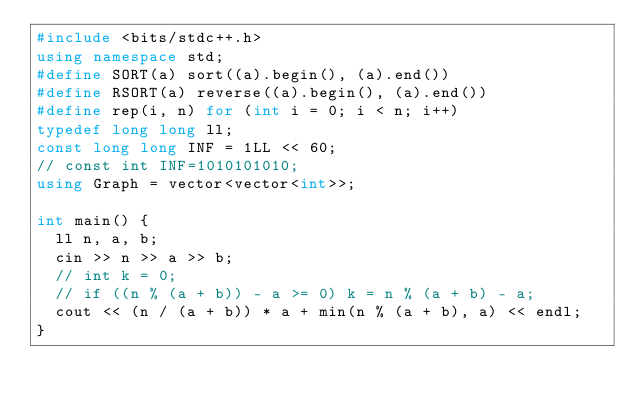Convert code to text. <code><loc_0><loc_0><loc_500><loc_500><_C++_>#include <bits/stdc++.h>
using namespace std;
#define SORT(a) sort((a).begin(), (a).end())
#define RSORT(a) reverse((a).begin(), (a).end())
#define rep(i, n) for (int i = 0; i < n; i++)
typedef long long ll;
const long long INF = 1LL << 60;
// const int INF=1010101010;
using Graph = vector<vector<int>>;

int main() {
  ll n, a, b;
  cin >> n >> a >> b;
  // int k = 0;
  // if ((n % (a + b)) - a >= 0) k = n % (a + b) - a;
  cout << (n / (a + b)) * a + min(n % (a + b), a) << endl;
}</code> 